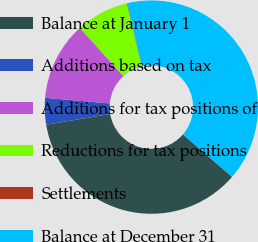Convert chart. <chart><loc_0><loc_0><loc_500><loc_500><pie_chart><fcel>Balance at January 1<fcel>Additions based on tax<fcel>Additions for tax positions of<fcel>Reductions for tax positions<fcel>Settlements<fcel>Balance at December 31<nl><fcel>36.01%<fcel>4.03%<fcel>11.93%<fcel>7.98%<fcel>0.08%<fcel>39.96%<nl></chart> 